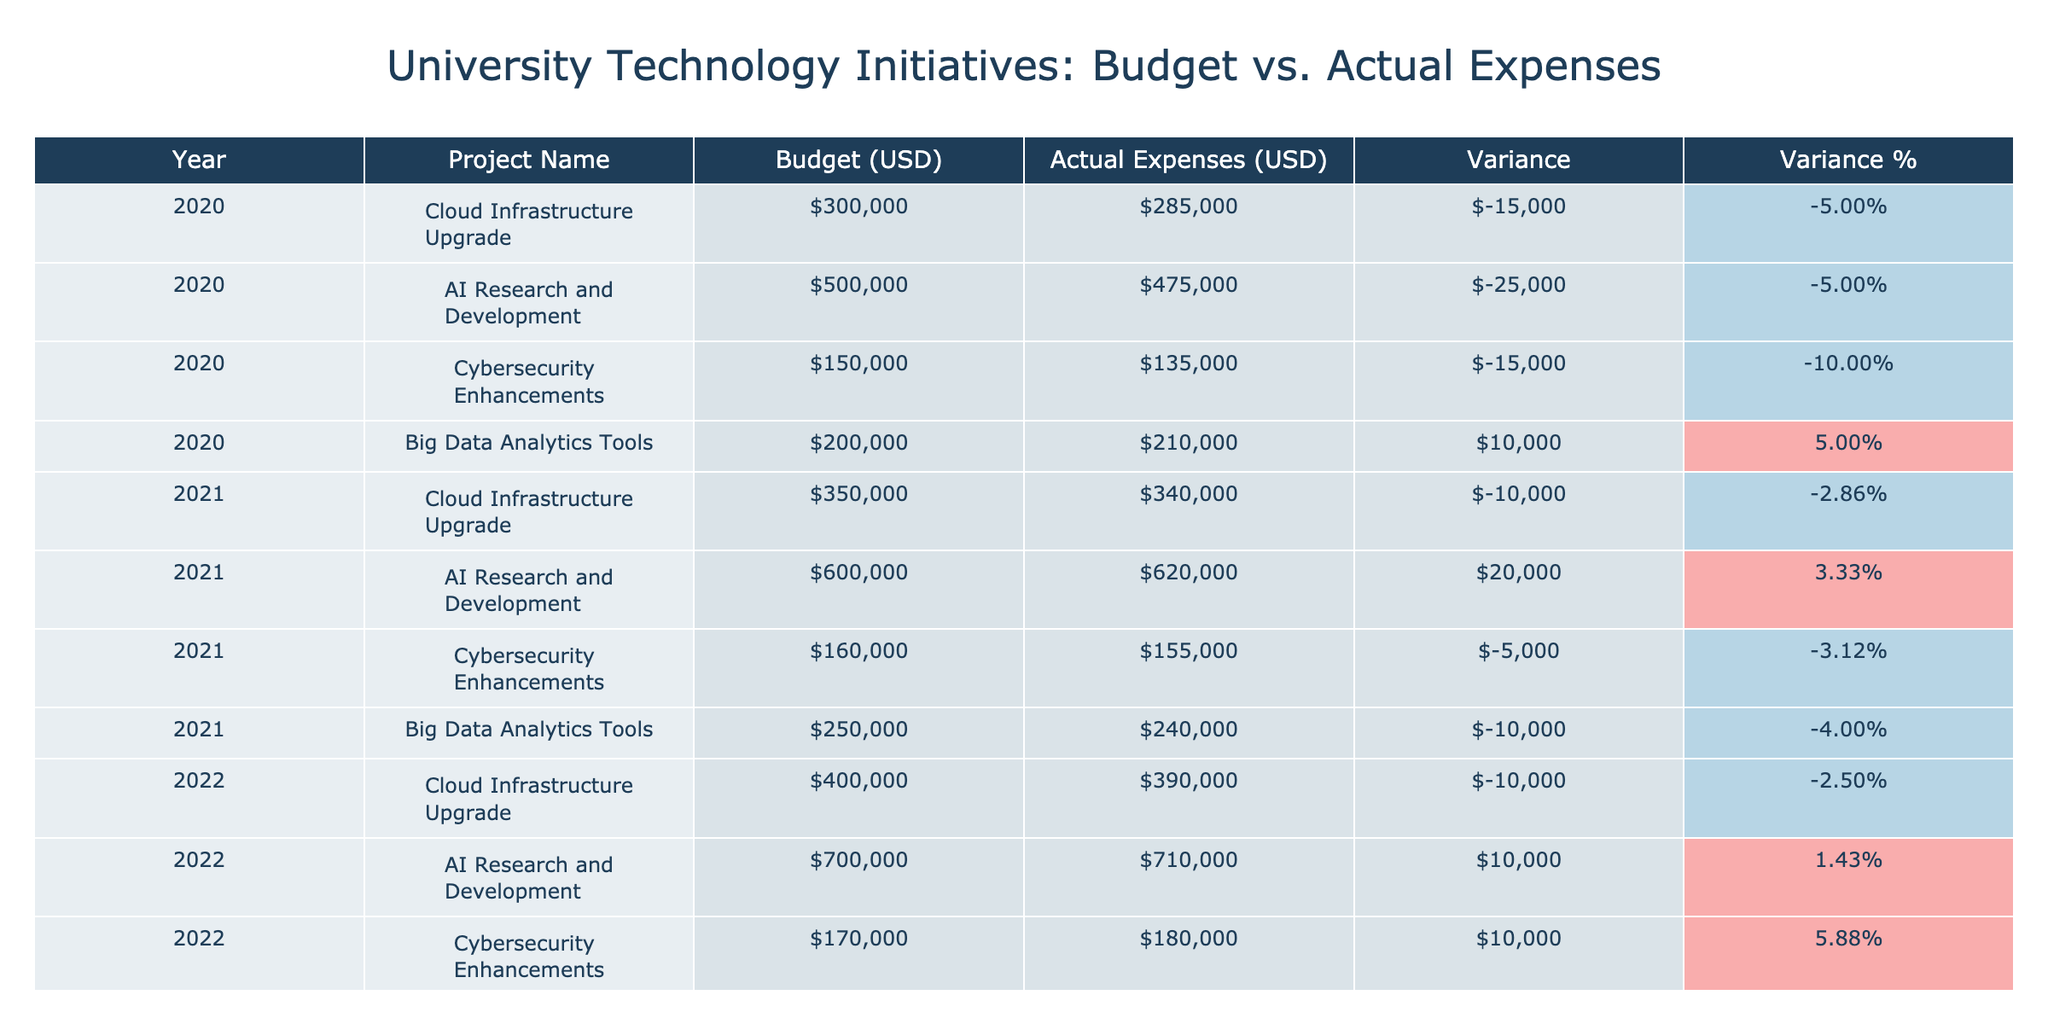What is the total budget for AI Research and Development from 2020 to 2023? The budget for AI Research and Development over the years is as follows: 2020 - $500,000, 2021 - $600,000, 2022 - $700,000, 2023 - $750,000. Summing these amounts gives us $500,000 + $600,000 + $700,000 + $750,000 = $2,550,000.
Answer: $2,550,000 In which year did the actual expenses exceed the budget for Cybersecurity Enhancements? Looking at the Cybersecurity Enhancements row for each year, I see that the actual expenses were below the budget in 2020 ($135,000 < $150,000), 2021 ($155,000 < $160,000), and 2022 ($180,000 > $170,000) where it actually exceeded the budget. In 2023, the actual expenses also remained below the budget ($175,000 < $180,000). So, the only year where actual expenses exceeded the budget was 2022.
Answer: 2022 What is the average variance percentage for the Big Data Analytics Tools project from 2020 to 2023? The variance percentages for Big Data Analytics Tools are: 2020: -5.00%, 2021: -4.00%, 2022: -3.33%, and 2023: 1.43%. To find the average variance percentage, I sum these percentages and divide by the number of years: (-5.00% - 4.00% - 3.33% + 1.43%) / 4 = -2.72%.
Answer: -2.72% Did the Cloud Infrastructure Upgrade project have actual expenses under budget every year? Analyzing the actual expenses for the Cloud Infrastructure Upgrade across the years: in 2020 it was $285,000 (under budget), in 2021 it was $340,000 (under budget), in 2022 it was $390,000 (under budget), and in 2023 it was $435,000 (under budget). Therefore, the project was under budget every year.
Answer: Yes Which project had the highest actual expenses in 2021? In 2021, the projects and their actual expenses are: Cloud Infrastructure Upgrade: $340,000, AI Research and Development: $620,000, Cybersecurity Enhancements: $155,000, and Big Data Analytics Tools: $240,000. The highest actual expense among these is for the AI Research and Development project at $620,000.
Answer: AI Research and Development 